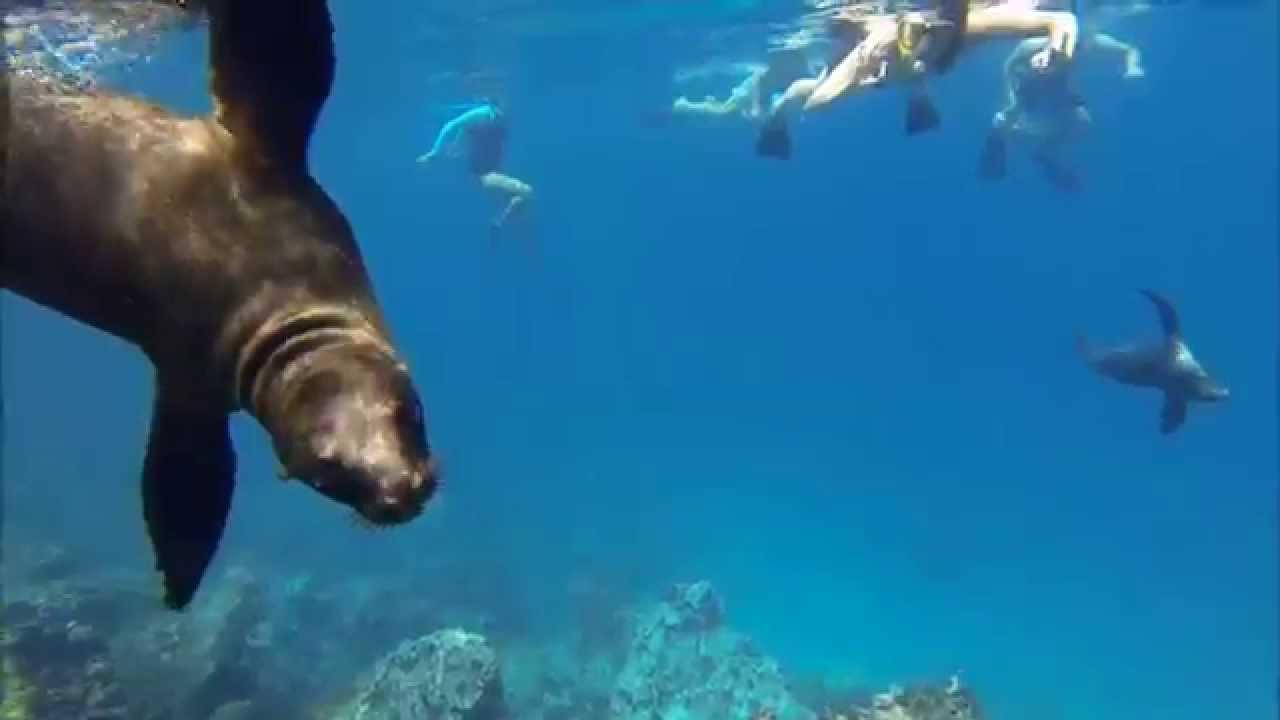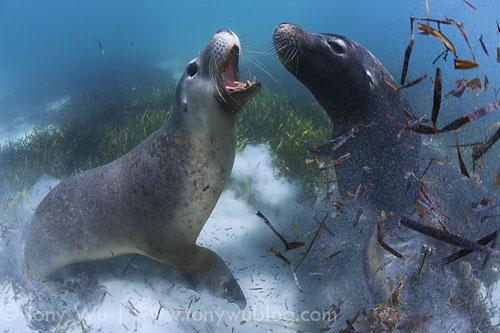The first image is the image on the left, the second image is the image on the right. Examine the images to the left and right. Is the description "An image includes at least one human diver swimming in the vicinity of a seal." accurate? Answer yes or no. Yes. The first image is the image on the left, the second image is the image on the right. Analyze the images presented: Is the assertion "A person is swimming with the animals in the image on the left." valid? Answer yes or no. Yes. 